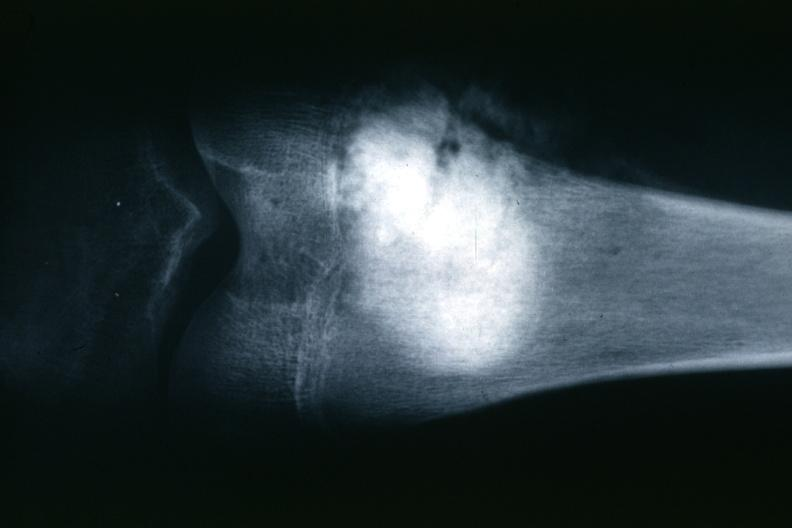s joints present?
Answer the question using a single word or phrase. Yes 